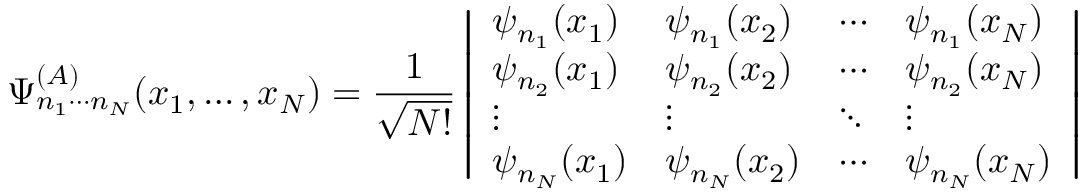Convert formula to latex. <formula><loc_0><loc_0><loc_500><loc_500>\Psi _ { n _ { 1 } \cdots n _ { N } } ^ { ( A ) } ( x _ { 1 } , \dots , x _ { N } ) = { \frac { 1 } { \sqrt { N ! } } } \left | { \begin{array} { l l l l } { \psi _ { n _ { 1 } } ( x _ { 1 } ) } & { \psi _ { n _ { 1 } } ( x _ { 2 } ) } & { \cdots } & { \psi _ { n _ { 1 } } ( x _ { N } ) } \\ { \psi _ { n _ { 2 } } ( x _ { 1 } ) } & { \psi _ { n _ { 2 } } ( x _ { 2 } ) } & { \cdots } & { \psi _ { n _ { 2 } } ( x _ { N } ) } \\ { \vdots } & { \vdots } & { \ddots } & { \vdots } \\ { \psi _ { n _ { N } } ( x _ { 1 } ) } & { \psi _ { n _ { N } } ( x _ { 2 } ) } & { \cdots } & { \psi _ { n _ { N } } ( x _ { N } ) } \end{array} } \right |</formula> 